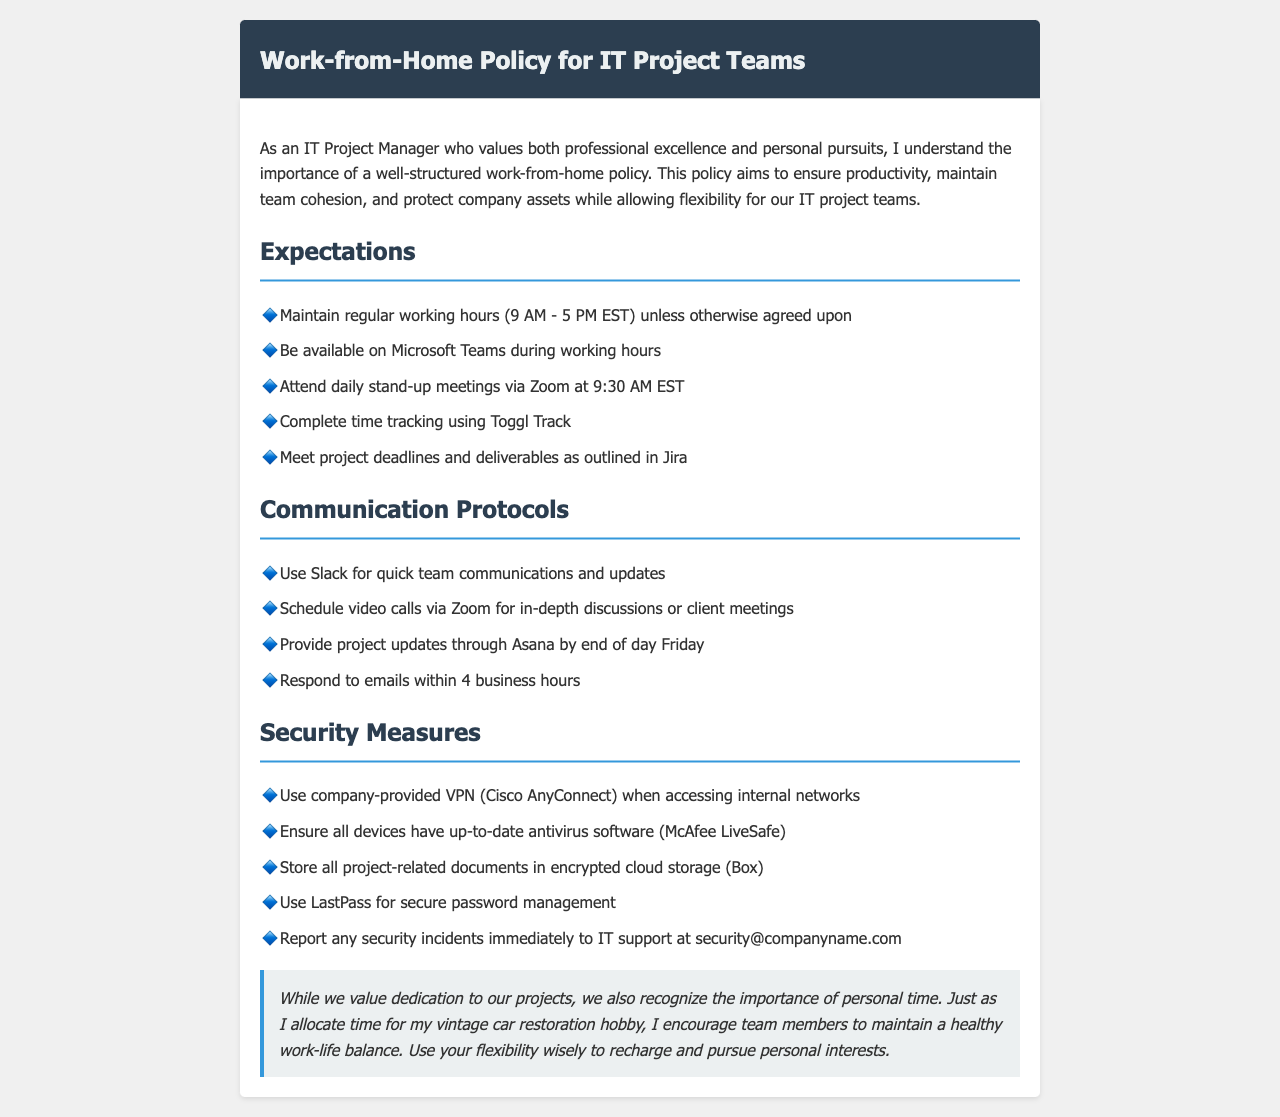What are the regular working hours? The document specifies that regular working hours are 9 AM - 5 PM EST.
Answer: 9 AM - 5 PM EST Which application is used for daily stand-up meetings? The document mentions that Zoom is used for daily stand-up meetings.
Answer: Zoom What time do daily stand-up meetings occur? According to the document, daily stand-up meetings occur at 9:30 AM EST.
Answer: 9:30 AM EST What tool should be used for time tracking? The document indicates that Toggl Track should be used for time tracking.
Answer: Toggl Track What is the response time for emails? The document states that emails should be responded to within 4 business hours.
Answer: 4 business hours What security measure is recommended for accessing internal networks? The document recommends using the company-provided VPN (Cisco AnyConnect) for accessing internal networks.
Answer: Cisco AnyConnect Where should project-related documents be stored? Project-related documents should be stored in encrypted cloud storage (Box), as per the document.
Answer: Box How often should project updates be provided? The document instructs that project updates should be provided through Asana by the end of day Friday.
Answer: By end of day Friday What is the email address to report security incidents? The document specifies that security incidents should be reported to IT support at security@companyname.com.
Answer: security@companyname.com 